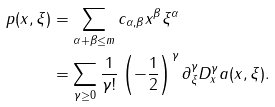Convert formula to latex. <formula><loc_0><loc_0><loc_500><loc_500>p ( x , \xi ) & = \sum _ { \alpha + \beta \leq m } c _ { \alpha , \beta } x ^ { \beta } \xi ^ { \alpha } \\ & = \sum _ { \gamma \geq 0 } \frac { 1 } { \gamma ! } \left ( - \frac { 1 } { 2 } \right ) ^ { \gamma } \partial ^ { \gamma } _ { \xi } D ^ { \gamma } _ { x } a ( x , \xi ) .</formula> 